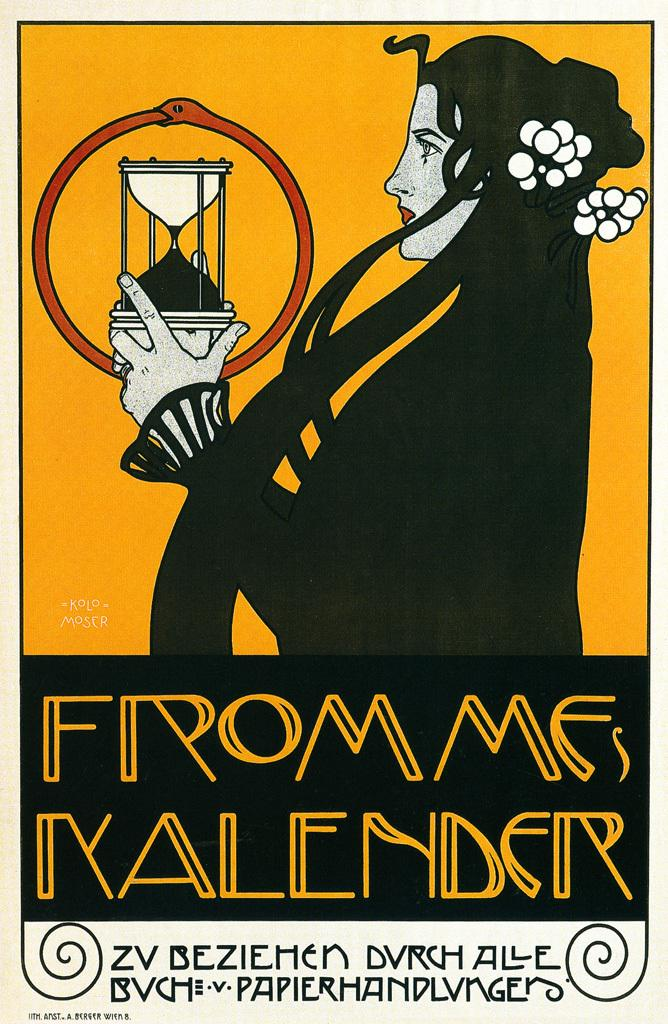<image>
Summarize the visual content of the image. An illustrated woman holds an hourglass in an Frommes Kalender ad. 